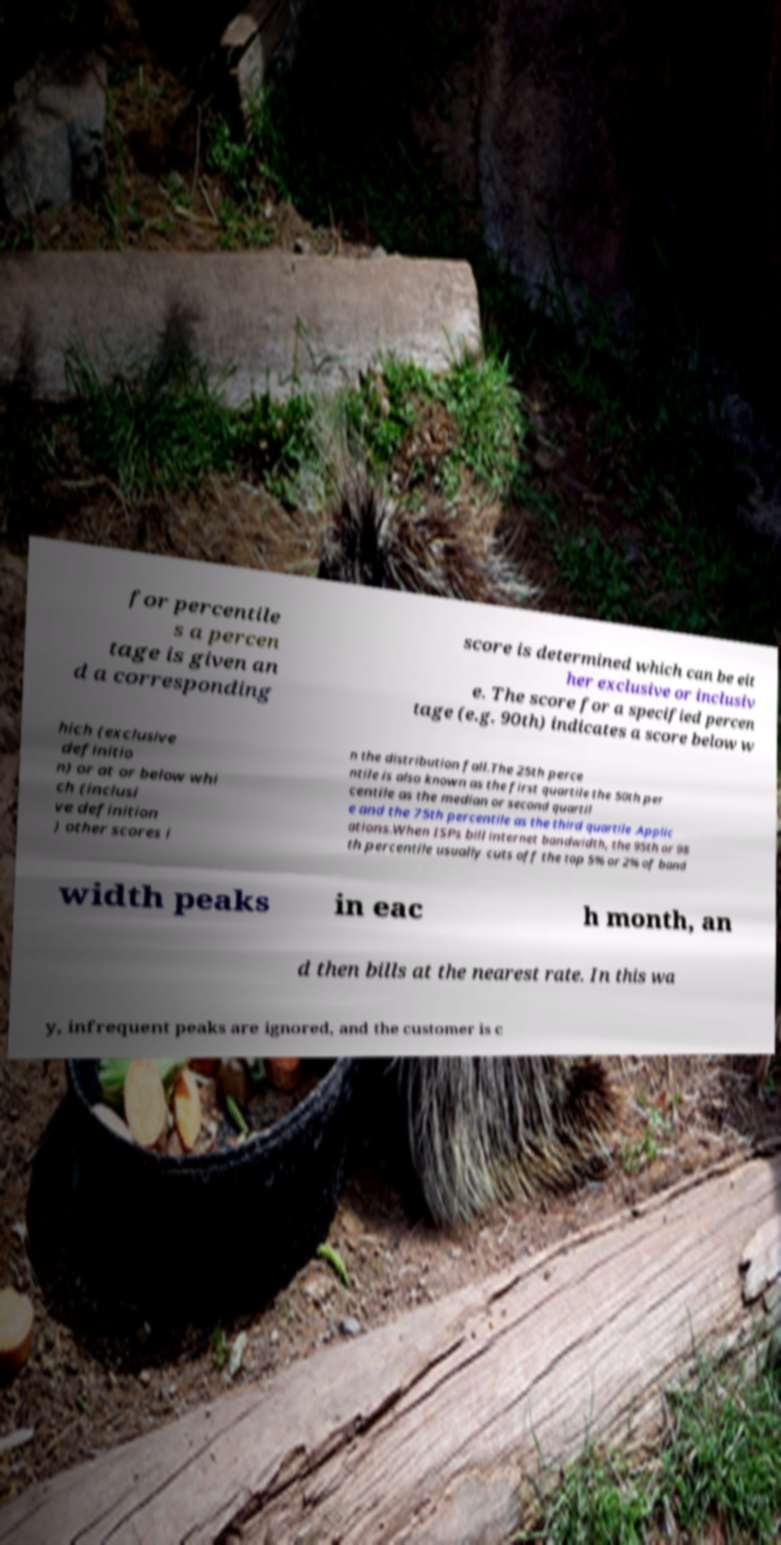Could you assist in decoding the text presented in this image and type it out clearly? for percentile s a percen tage is given an d a corresponding score is determined which can be eit her exclusive or inclusiv e. The score for a specified percen tage (e.g. 90th) indicates a score below w hich (exclusive definitio n) or at or below whi ch (inclusi ve definition ) other scores i n the distribution fall.The 25th perce ntile is also known as the first quartile the 50th per centile as the median or second quartil e and the 75th percentile as the third quartile .Applic ations.When ISPs bill internet bandwidth, the 95th or 98 th percentile usually cuts off the top 5% or 2% of band width peaks in eac h month, an d then bills at the nearest rate. In this wa y, infrequent peaks are ignored, and the customer is c 